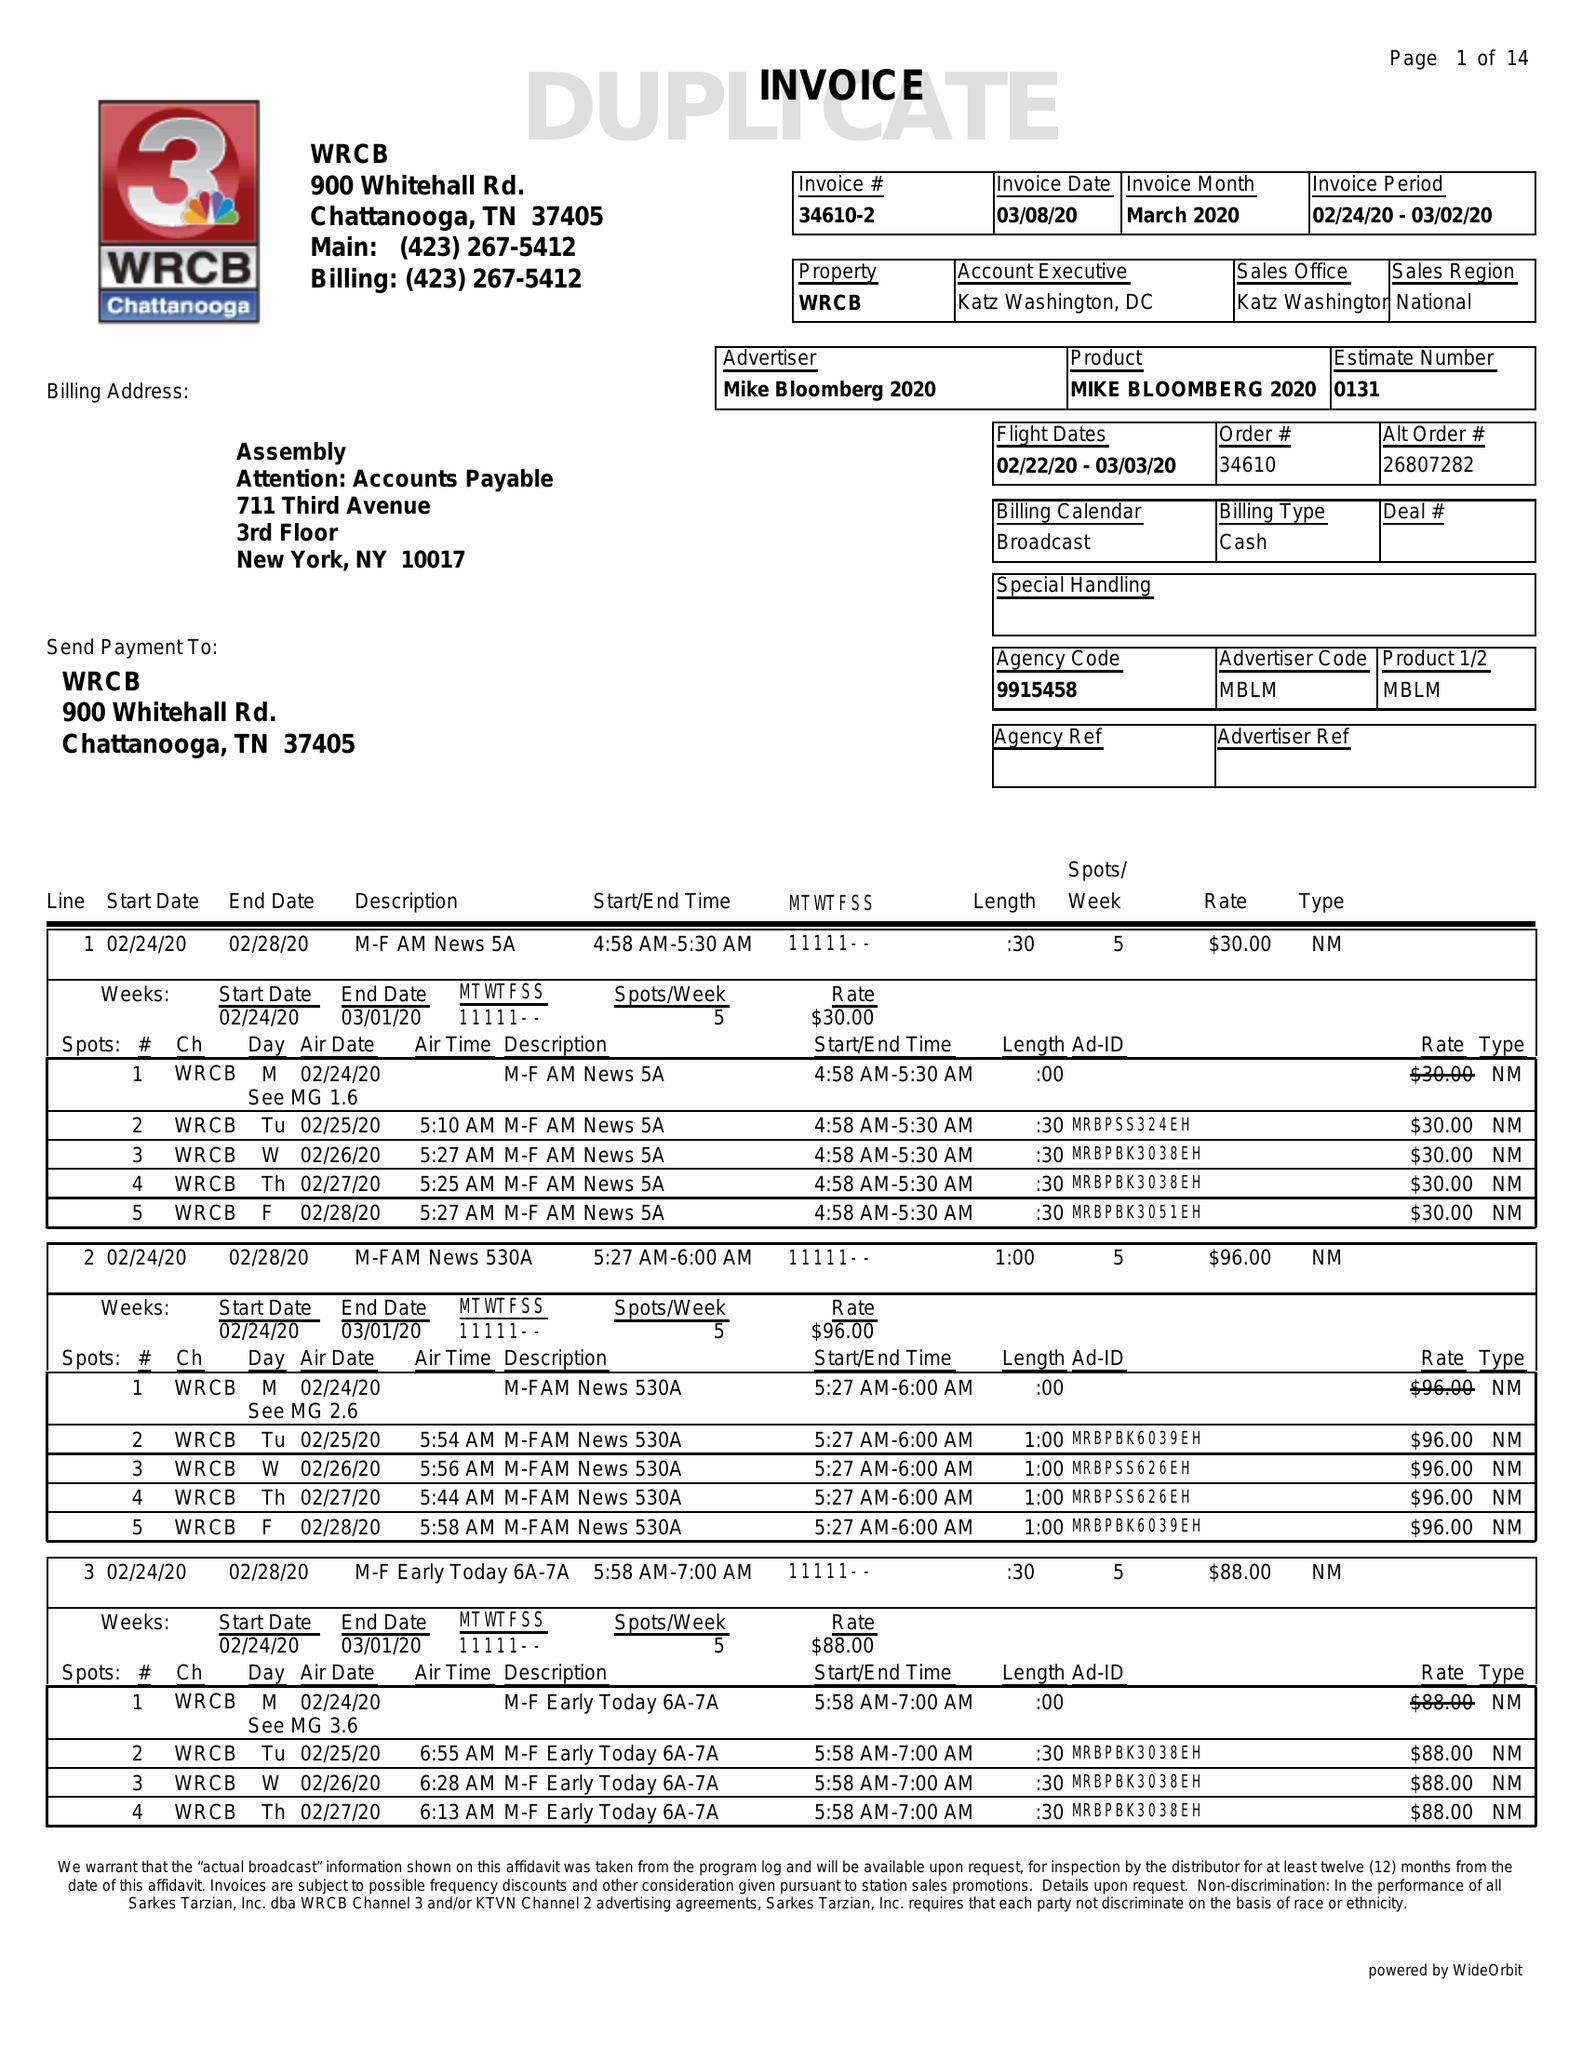What is the value for the gross_amount?
Answer the question using a single word or phrase. 24199.00 